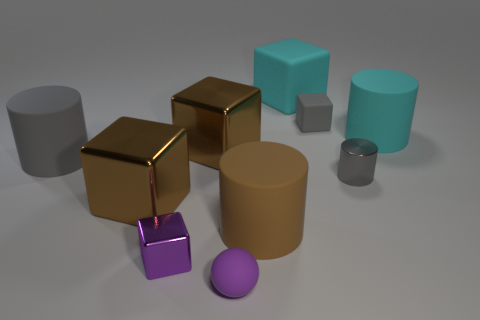Subtract all tiny gray matte blocks. How many blocks are left? 4 Subtract all brown cylinders. How many cylinders are left? 3 Subtract all purple cubes. How many gray cylinders are left? 2 Subtract all cylinders. How many objects are left? 6 Subtract 1 cylinders. How many cylinders are left? 3 Subtract all cyan cubes. Subtract all green cylinders. How many cubes are left? 4 Subtract all small brown cubes. Subtract all big cyan things. How many objects are left? 8 Add 1 tiny gray cylinders. How many tiny gray cylinders are left? 2 Add 5 gray matte objects. How many gray matte objects exist? 7 Subtract 0 blue blocks. How many objects are left? 10 